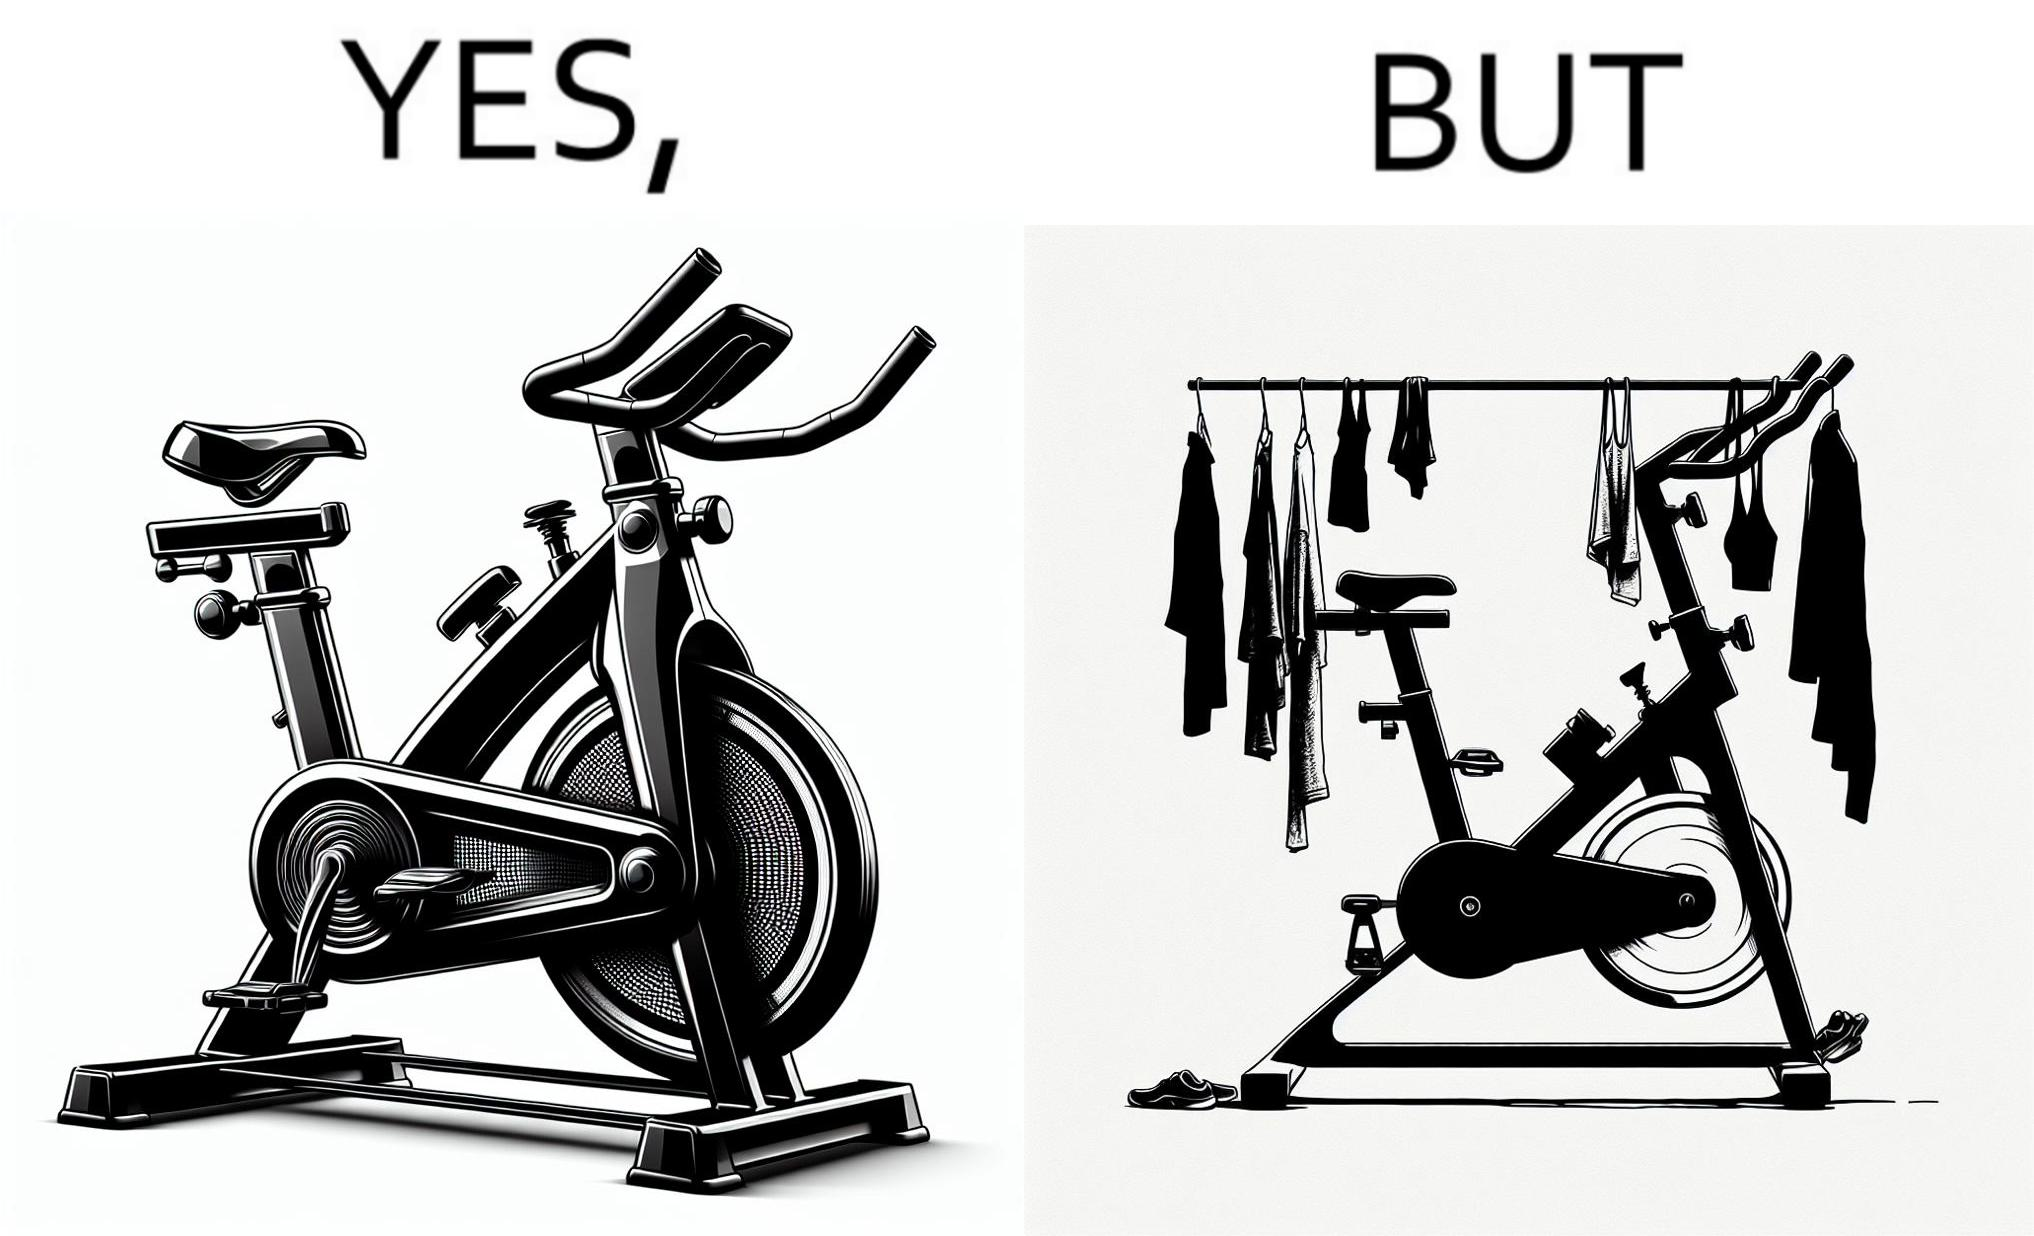What is shown in the left half versus the right half of this image? In the left part of the image: An exercise bike In the right part of the image: An exercise bike being used to hang clothes and other items 